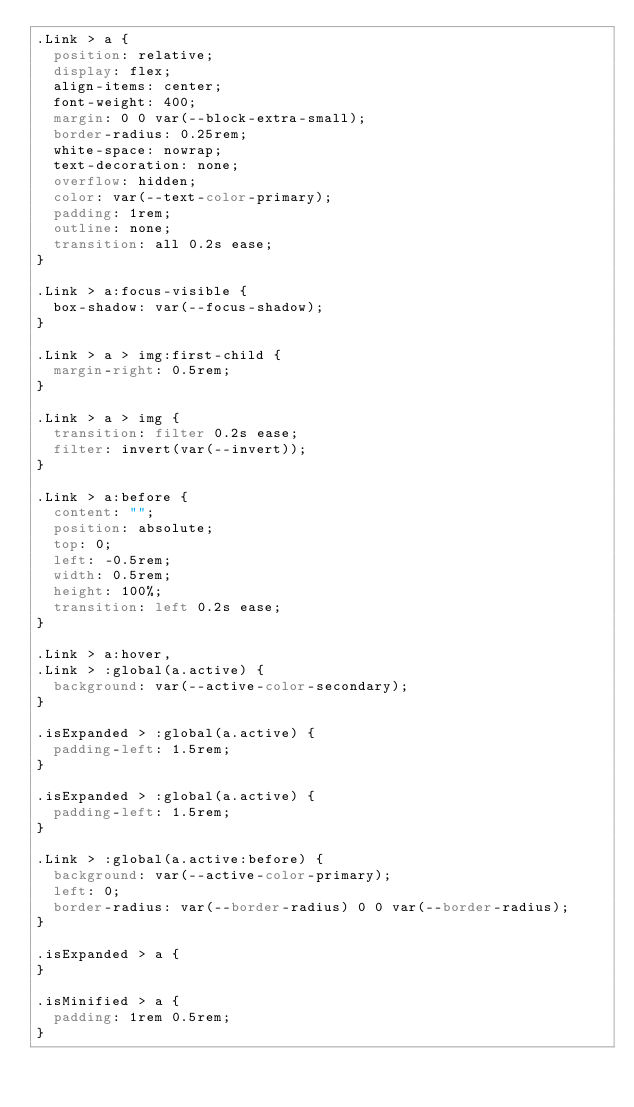<code> <loc_0><loc_0><loc_500><loc_500><_CSS_>.Link > a {
  position: relative;
  display: flex;
  align-items: center;
  font-weight: 400;
  margin: 0 0 var(--block-extra-small);
  border-radius: 0.25rem;
  white-space: nowrap;
  text-decoration: none;
  overflow: hidden;
  color: var(--text-color-primary);
  padding: 1rem;
  outline: none;
  transition: all 0.2s ease;
}

.Link > a:focus-visible {
  box-shadow: var(--focus-shadow);
}

.Link > a > img:first-child {
  margin-right: 0.5rem;
}

.Link > a > img {
  transition: filter 0.2s ease;
  filter: invert(var(--invert));
}

.Link > a:before {
  content: "";
  position: absolute;
  top: 0;
  left: -0.5rem;
  width: 0.5rem;
  height: 100%;
  transition: left 0.2s ease;
}

.Link > a:hover,
.Link > :global(a.active) {
  background: var(--active-color-secondary);
}

.isExpanded > :global(a.active) {
  padding-left: 1.5rem;
}

.isExpanded > :global(a.active) {
  padding-left: 1.5rem;
}

.Link > :global(a.active:before) {
  background: var(--active-color-primary);
  left: 0;
  border-radius: var(--border-radius) 0 0 var(--border-radius);
}

.isExpanded > a {
}

.isMinified > a {
  padding: 1rem 0.5rem;
}
</code> 